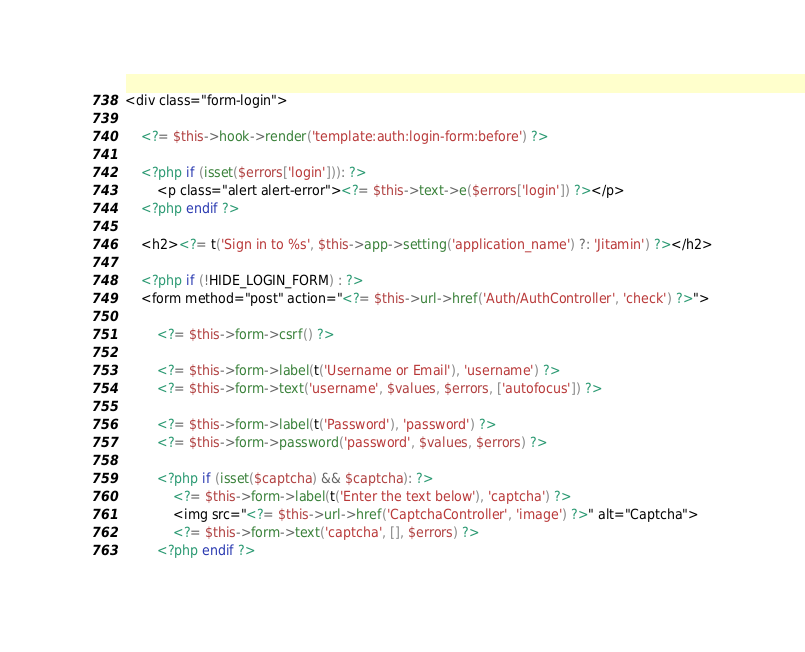<code> <loc_0><loc_0><loc_500><loc_500><_PHP_><div class="form-login">

    <?= $this->hook->render('template:auth:login-form:before') ?>

    <?php if (isset($errors['login'])): ?>
        <p class="alert alert-error"><?= $this->text->e($errors['login']) ?></p>
    <?php endif ?>

    <h2><?= t('Sign in to %s', $this->app->setting('application_name') ?: 'Jitamin') ?></h2>

    <?php if (!HIDE_LOGIN_FORM) : ?>
    <form method="post" action="<?= $this->url->href('Auth/AuthController', 'check') ?>">

        <?= $this->form->csrf() ?>

        <?= $this->form->label(t('Username or Email'), 'username') ?>
        <?= $this->form->text('username', $values, $errors, ['autofocus']) ?>

        <?= $this->form->label(t('Password'), 'password') ?>
        <?= $this->form->password('password', $values, $errors) ?>

        <?php if (isset($captcha) && $captcha): ?>
            <?= $this->form->label(t('Enter the text below'), 'captcha') ?>
            <img src="<?= $this->url->href('CaptchaController', 'image') ?>" alt="Captcha">
            <?= $this->form->text('captcha', [], $errors) ?>
        <?php endif ?>
</code> 